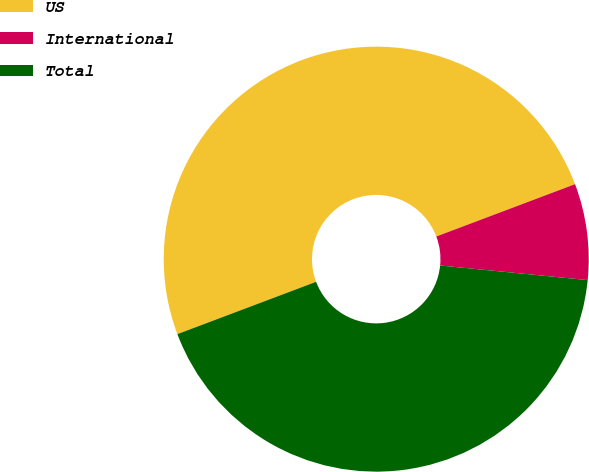Convert chart. <chart><loc_0><loc_0><loc_500><loc_500><pie_chart><fcel>US<fcel>International<fcel>Total<nl><fcel>50.0%<fcel>7.31%<fcel>42.69%<nl></chart> 